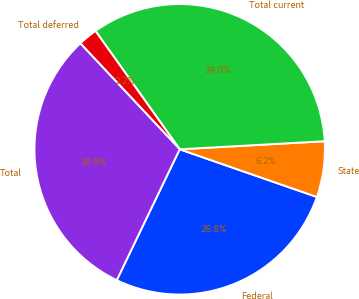Convert chart to OTSL. <chart><loc_0><loc_0><loc_500><loc_500><pie_chart><fcel>Federal<fcel>State<fcel>Total current<fcel>Total deferred<fcel>Total<nl><fcel>26.81%<fcel>6.21%<fcel>33.96%<fcel>2.15%<fcel>30.87%<nl></chart> 